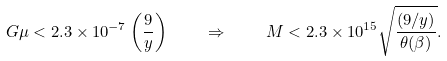Convert formula to latex. <formula><loc_0><loc_0><loc_500><loc_500>G \mu < 2 . 3 \times 1 0 ^ { - 7 } \left ( \frac { 9 } { y } \right ) \quad \Rightarrow \quad M < 2 . 3 \times 1 0 ^ { 1 5 } \sqrt { \frac { ( 9 / y ) } { \theta ( \beta ) } } .</formula> 